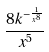Convert formula to latex. <formula><loc_0><loc_0><loc_500><loc_500>\frac { 8 k ^ { - \frac { 1 } { x ^ { 8 } } } } { x ^ { 5 } }</formula> 